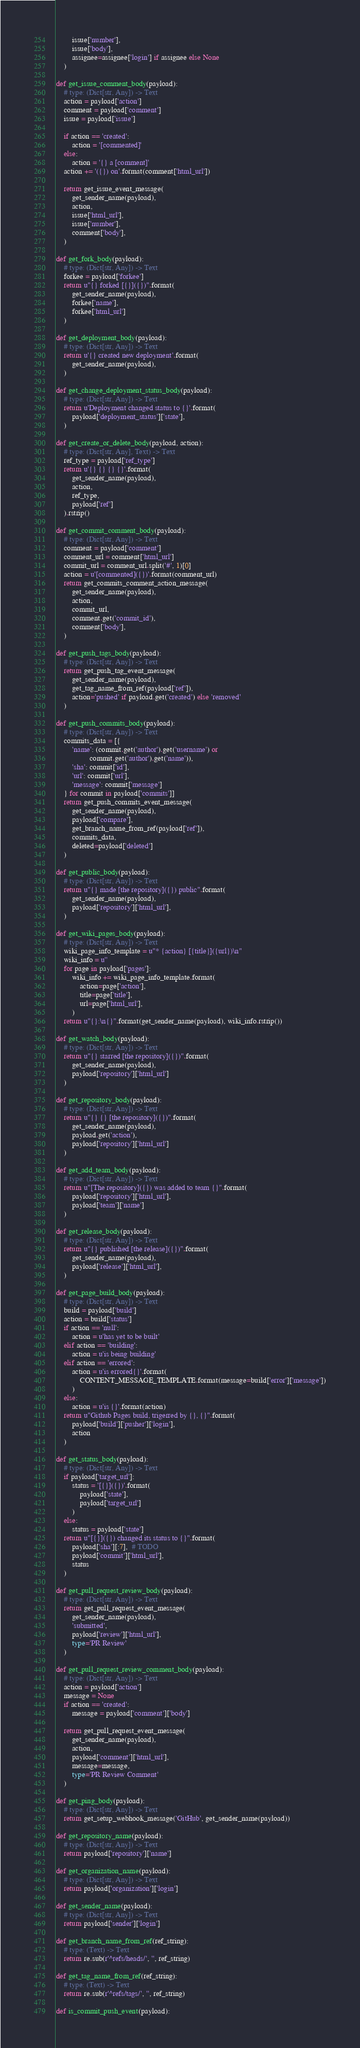Convert code to text. <code><loc_0><loc_0><loc_500><loc_500><_Python_>        issue['number'],
        issue['body'],
        assignee=assignee['login'] if assignee else None
    )

def get_issue_comment_body(payload):
    # type: (Dict[str, Any]) -> Text
    action = payload['action']
    comment = payload['comment']
    issue = payload['issue']

    if action == 'created':
        action = '[commented]'
    else:
        action = '{} a [comment]'
    action += '({}) on'.format(comment['html_url'])

    return get_issue_event_message(
        get_sender_name(payload),
        action,
        issue['html_url'],
        issue['number'],
        comment['body'],
    )

def get_fork_body(payload):
    # type: (Dict[str, Any]) -> Text
    forkee = payload['forkee']
    return u"{} forked [{}]({})".format(
        get_sender_name(payload),
        forkee['name'],
        forkee['html_url']
    )

def get_deployment_body(payload):
    # type: (Dict[str, Any]) -> Text
    return u'{} created new deployment'.format(
        get_sender_name(payload),
    )

def get_change_deployment_status_body(payload):
    # type: (Dict[str, Any]) -> Text
    return u'Deployment changed status to {}'.format(
        payload['deployment_status']['state'],
    )

def get_create_or_delete_body(payload, action):
    # type: (Dict[str, Any], Text) -> Text
    ref_type = payload['ref_type']
    return u'{} {} {} {}'.format(
        get_sender_name(payload),
        action,
        ref_type,
        payload['ref']
    ).rstrip()

def get_commit_comment_body(payload):
    # type: (Dict[str, Any]) -> Text
    comment = payload['comment']
    comment_url = comment['html_url']
    commit_url = comment_url.split('#', 1)[0]
    action = u'[commented]({})'.format(comment_url)
    return get_commits_comment_action_message(
        get_sender_name(payload),
        action,
        commit_url,
        comment.get('commit_id'),
        comment['body'],
    )

def get_push_tags_body(payload):
    # type: (Dict[str, Any]) -> Text
    return get_push_tag_event_message(
        get_sender_name(payload),
        get_tag_name_from_ref(payload['ref']),
        action='pushed' if payload.get('created') else 'removed'
    )

def get_push_commits_body(payload):
    # type: (Dict[str, Any]) -> Text
    commits_data = [{
        'name': (commit.get('author').get('username') or
                 commit.get('author').get('name')),
        'sha': commit['id'],
        'url': commit['url'],
        'message': commit['message']
    } for commit in payload['commits']]
    return get_push_commits_event_message(
        get_sender_name(payload),
        payload['compare'],
        get_branch_name_from_ref(payload['ref']),
        commits_data,
        deleted=payload['deleted']
    )

def get_public_body(payload):
    # type: (Dict[str, Any]) -> Text
    return u"{} made [the repository]({}) public".format(
        get_sender_name(payload),
        payload['repository']['html_url'],
    )

def get_wiki_pages_body(payload):
    # type: (Dict[str, Any]) -> Text
    wiki_page_info_template = u"* {action} [{title}]({url})\n"
    wiki_info = u''
    for page in payload['pages']:
        wiki_info += wiki_page_info_template.format(
            action=page['action'],
            title=page['title'],
            url=page['html_url'],
        )
    return u"{}:\n{}".format(get_sender_name(payload), wiki_info.rstrip())

def get_watch_body(payload):
    # type: (Dict[str, Any]) -> Text
    return u"{} starred [the repository]({})".format(
        get_sender_name(payload),
        payload['repository']['html_url']
    )

def get_repository_body(payload):
    # type: (Dict[str, Any]) -> Text
    return u"{} {} [the repository]({})".format(
        get_sender_name(payload),
        payload.get('action'),
        payload['repository']['html_url']
    )

def get_add_team_body(payload):
    # type: (Dict[str, Any]) -> Text
    return u"[The repository]({}) was added to team {}".format(
        payload['repository']['html_url'],
        payload['team']['name']
    )

def get_release_body(payload):
    # type: (Dict[str, Any]) -> Text
    return u"{} published [the release]({})".format(
        get_sender_name(payload),
        payload['release']['html_url'],
    )

def get_page_build_body(payload):
    # type: (Dict[str, Any]) -> Text
    build = payload['build']
    action = build['status']
    if action == 'null':
        action = u'has yet to be built'
    elif action == 'building':
        action = u'is being building'
    elif action == 'errored':
        action = u'is errored{}'.format(
            CONTENT_MESSAGE_TEMPLATE.format(message=build['error']['message'])
        )
    else:
        action = u'is {}'.format(action)
    return u"Github Pages build, trigerred by {}, {}".format(
        payload['build']['pusher']['login'],
        action
    )

def get_status_body(payload):
    # type: (Dict[str, Any]) -> Text
    if payload['target_url']:
        status = '[{}]({})'.format(
            payload['state'],
            payload['target_url']
        )
    else:
        status = payload['state']
    return u"[{}]({}) changed its status to {}".format(
        payload['sha'][:7],  # TODO
        payload['commit']['html_url'],
        status
    )

def get_pull_request_review_body(payload):
    # type: (Dict[str, Any]) -> Text
    return get_pull_request_event_message(
        get_sender_name(payload),
        'submitted',
        payload['review']['html_url'],
        type='PR Review'
    )

def get_pull_request_review_comment_body(payload):
    # type: (Dict[str, Any]) -> Text
    action = payload['action']
    message = None
    if action == 'created':
        message = payload['comment']['body']

    return get_pull_request_event_message(
        get_sender_name(payload),
        action,
        payload['comment']['html_url'],
        message=message,
        type='PR Review Comment'
    )

def get_ping_body(payload):
    # type: (Dict[str, Any]) -> Text
    return get_setup_webhook_message('GitHub', get_sender_name(payload))

def get_repository_name(payload):
    # type: (Dict[str, Any]) -> Text
    return payload['repository']['name']

def get_organization_name(payload):
    # type: (Dict[str, Any]) -> Text
    return payload['organization']['login']

def get_sender_name(payload):
    # type: (Dict[str, Any]) -> Text
    return payload['sender']['login']

def get_branch_name_from_ref(ref_string):
    # type: (Text) -> Text
    return re.sub(r'^refs/heads/', '', ref_string)

def get_tag_name_from_ref(ref_string):
    # type: (Text) -> Text
    return re.sub(r'^refs/tags/', '', ref_string)

def is_commit_push_event(payload):</code> 